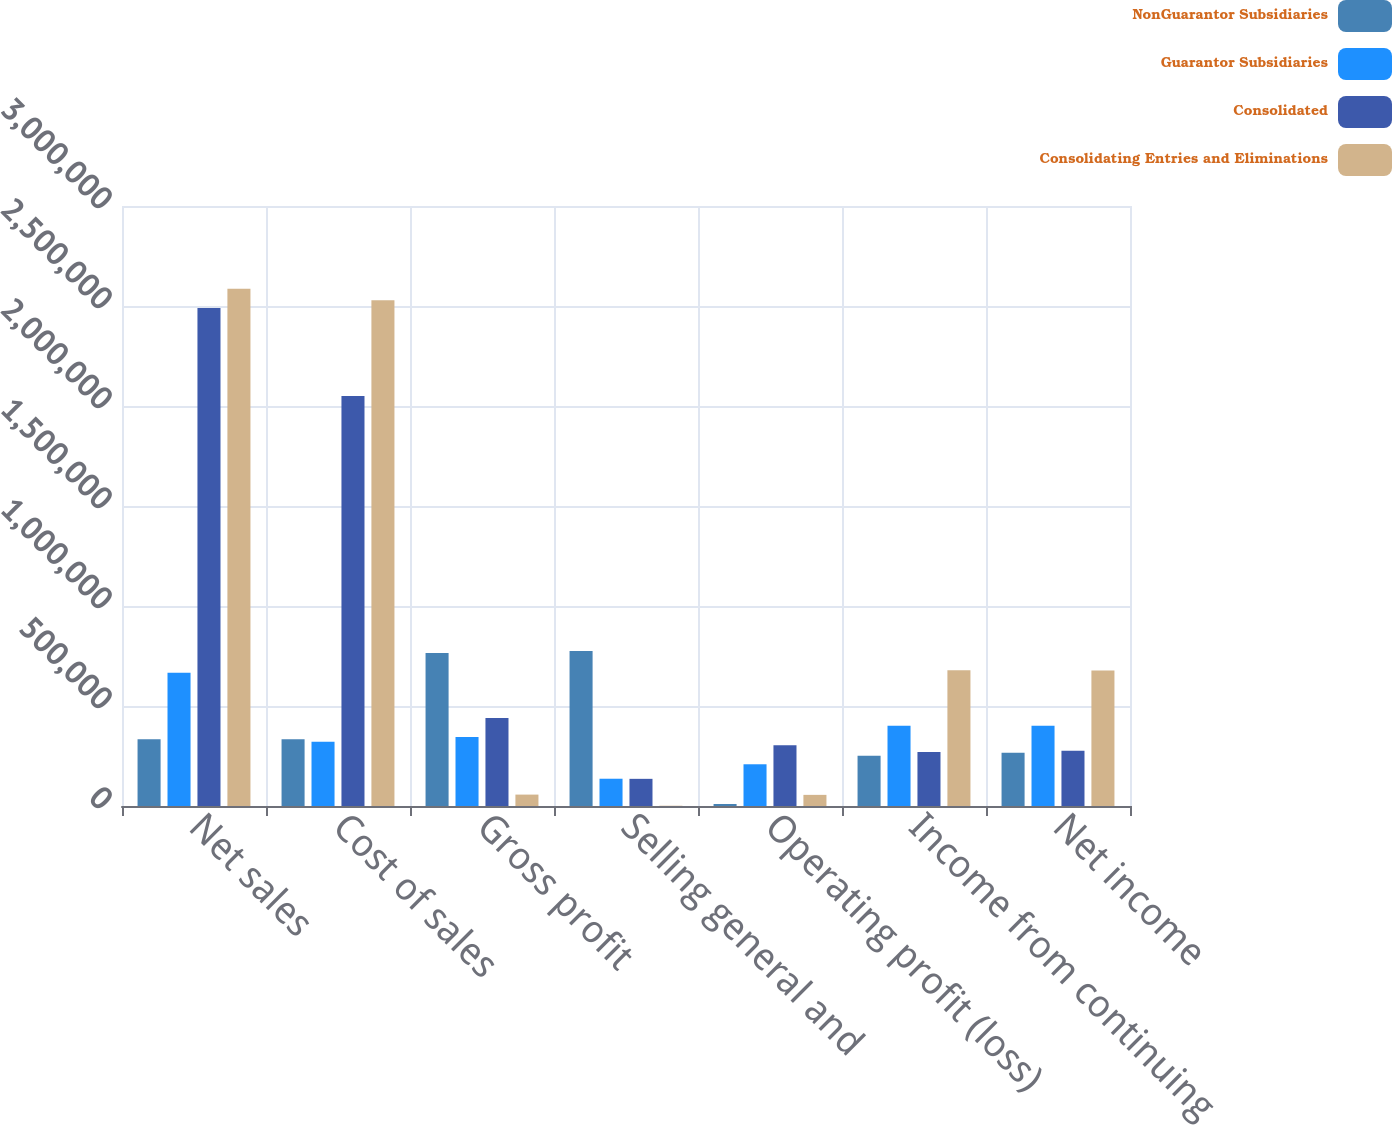Convert chart. <chart><loc_0><loc_0><loc_500><loc_500><stacked_bar_chart><ecel><fcel>Net sales<fcel>Cost of sales<fcel>Gross profit<fcel>Selling general and<fcel>Operating profit (loss)<fcel>Income from continuing<fcel>Net income<nl><fcel>NonGuarantor Subsidiaries<fcel>333135<fcel>333135<fcel>765410<fcel>775316<fcel>9906<fcel>250633<fcel>266688<nl><fcel>Guarantor Subsidiaries<fcel>666270<fcel>321305<fcel>344965<fcel>136336<fcel>208629<fcel>401235<fcel>401235<nl><fcel>Consolidated<fcel>2.48997e+06<fcel>2.0501e+06<fcel>439869<fcel>135805<fcel>304064<fcel>270024<fcel>276471<nl><fcel>Consolidating Entries and Eliminations<fcel>2.58615e+06<fcel>2.52912e+06<fcel>57036<fcel>1376<fcel>55660<fcel>679323<fcel>677706<nl></chart> 